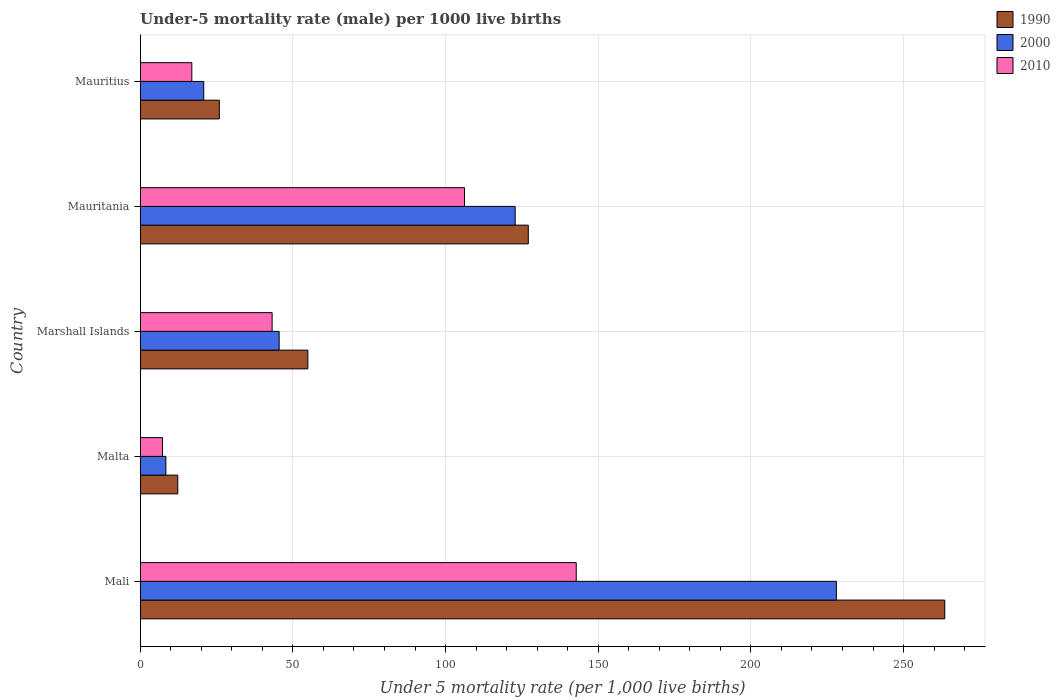How many different coloured bars are there?
Your answer should be compact. 3. Are the number of bars on each tick of the Y-axis equal?
Your answer should be very brief. Yes. How many bars are there on the 2nd tick from the bottom?
Keep it short and to the point. 3. What is the label of the 1st group of bars from the top?
Keep it short and to the point. Mauritius. In how many cases, is the number of bars for a given country not equal to the number of legend labels?
Your answer should be very brief. 0. Across all countries, what is the maximum under-five mortality rate in 1990?
Provide a succinct answer. 263.5. In which country was the under-five mortality rate in 1990 maximum?
Make the answer very short. Mali. In which country was the under-five mortality rate in 2010 minimum?
Your response must be concise. Malta. What is the total under-five mortality rate in 2000 in the graph?
Provide a short and direct response. 425.5. What is the difference between the under-five mortality rate in 1990 in Mali and that in Mauritius?
Make the answer very short. 237.6. What is the difference between the under-five mortality rate in 2000 in Mauritius and the under-five mortality rate in 1990 in Mauritania?
Your answer should be very brief. -106.3. What is the average under-five mortality rate in 1990 per country?
Offer a very short reply. 96.74. What is the difference between the under-five mortality rate in 2010 and under-five mortality rate in 1990 in Marshall Islands?
Make the answer very short. -11.7. In how many countries, is the under-five mortality rate in 2000 greater than 150 ?
Provide a short and direct response. 1. What is the ratio of the under-five mortality rate in 2010 in Mali to that in Marshall Islands?
Provide a succinct answer. 3.31. What is the difference between the highest and the second highest under-five mortality rate in 2000?
Provide a succinct answer. 105.2. What is the difference between the highest and the lowest under-five mortality rate in 2000?
Ensure brevity in your answer.  219.6. In how many countries, is the under-five mortality rate in 1990 greater than the average under-five mortality rate in 1990 taken over all countries?
Give a very brief answer. 2. What does the 3rd bar from the top in Mauritania represents?
Your answer should be compact. 1990. What does the 2nd bar from the bottom in Malta represents?
Keep it short and to the point. 2000. How many bars are there?
Provide a succinct answer. 15. Does the graph contain any zero values?
Provide a short and direct response. No. Does the graph contain grids?
Give a very brief answer. Yes. How many legend labels are there?
Your answer should be very brief. 3. What is the title of the graph?
Your response must be concise. Under-5 mortality rate (male) per 1000 live births. Does "1988" appear as one of the legend labels in the graph?
Provide a short and direct response. No. What is the label or title of the X-axis?
Your response must be concise. Under 5 mortality rate (per 1,0 live births). What is the Under 5 mortality rate (per 1,000 live births) of 1990 in Mali?
Offer a very short reply. 263.5. What is the Under 5 mortality rate (per 1,000 live births) of 2000 in Mali?
Your response must be concise. 228. What is the Under 5 mortality rate (per 1,000 live births) in 2010 in Mali?
Make the answer very short. 142.8. What is the Under 5 mortality rate (per 1,000 live births) in 1990 in Malta?
Offer a very short reply. 12.3. What is the Under 5 mortality rate (per 1,000 live births) of 2000 in Malta?
Provide a short and direct response. 8.4. What is the Under 5 mortality rate (per 1,000 live births) in 1990 in Marshall Islands?
Your answer should be compact. 54.9. What is the Under 5 mortality rate (per 1,000 live births) in 2000 in Marshall Islands?
Ensure brevity in your answer.  45.5. What is the Under 5 mortality rate (per 1,000 live births) in 2010 in Marshall Islands?
Give a very brief answer. 43.2. What is the Under 5 mortality rate (per 1,000 live births) of 1990 in Mauritania?
Your answer should be very brief. 127.1. What is the Under 5 mortality rate (per 1,000 live births) of 2000 in Mauritania?
Provide a succinct answer. 122.8. What is the Under 5 mortality rate (per 1,000 live births) of 2010 in Mauritania?
Give a very brief answer. 106.2. What is the Under 5 mortality rate (per 1,000 live births) of 1990 in Mauritius?
Offer a very short reply. 25.9. What is the Under 5 mortality rate (per 1,000 live births) in 2000 in Mauritius?
Provide a succinct answer. 20.8. What is the Under 5 mortality rate (per 1,000 live births) in 2010 in Mauritius?
Give a very brief answer. 16.9. Across all countries, what is the maximum Under 5 mortality rate (per 1,000 live births) in 1990?
Give a very brief answer. 263.5. Across all countries, what is the maximum Under 5 mortality rate (per 1,000 live births) in 2000?
Offer a very short reply. 228. Across all countries, what is the maximum Under 5 mortality rate (per 1,000 live births) in 2010?
Your response must be concise. 142.8. What is the total Under 5 mortality rate (per 1,000 live births) of 1990 in the graph?
Your answer should be compact. 483.7. What is the total Under 5 mortality rate (per 1,000 live births) in 2000 in the graph?
Your response must be concise. 425.5. What is the total Under 5 mortality rate (per 1,000 live births) in 2010 in the graph?
Make the answer very short. 316.4. What is the difference between the Under 5 mortality rate (per 1,000 live births) in 1990 in Mali and that in Malta?
Your response must be concise. 251.2. What is the difference between the Under 5 mortality rate (per 1,000 live births) of 2000 in Mali and that in Malta?
Your answer should be very brief. 219.6. What is the difference between the Under 5 mortality rate (per 1,000 live births) of 2010 in Mali and that in Malta?
Provide a succinct answer. 135.5. What is the difference between the Under 5 mortality rate (per 1,000 live births) of 1990 in Mali and that in Marshall Islands?
Provide a succinct answer. 208.6. What is the difference between the Under 5 mortality rate (per 1,000 live births) in 2000 in Mali and that in Marshall Islands?
Give a very brief answer. 182.5. What is the difference between the Under 5 mortality rate (per 1,000 live births) of 2010 in Mali and that in Marshall Islands?
Your answer should be compact. 99.6. What is the difference between the Under 5 mortality rate (per 1,000 live births) in 1990 in Mali and that in Mauritania?
Your answer should be compact. 136.4. What is the difference between the Under 5 mortality rate (per 1,000 live births) in 2000 in Mali and that in Mauritania?
Make the answer very short. 105.2. What is the difference between the Under 5 mortality rate (per 1,000 live births) of 2010 in Mali and that in Mauritania?
Provide a succinct answer. 36.6. What is the difference between the Under 5 mortality rate (per 1,000 live births) in 1990 in Mali and that in Mauritius?
Offer a terse response. 237.6. What is the difference between the Under 5 mortality rate (per 1,000 live births) of 2000 in Mali and that in Mauritius?
Your response must be concise. 207.2. What is the difference between the Under 5 mortality rate (per 1,000 live births) in 2010 in Mali and that in Mauritius?
Make the answer very short. 125.9. What is the difference between the Under 5 mortality rate (per 1,000 live births) of 1990 in Malta and that in Marshall Islands?
Your answer should be compact. -42.6. What is the difference between the Under 5 mortality rate (per 1,000 live births) in 2000 in Malta and that in Marshall Islands?
Your answer should be compact. -37.1. What is the difference between the Under 5 mortality rate (per 1,000 live births) of 2010 in Malta and that in Marshall Islands?
Ensure brevity in your answer.  -35.9. What is the difference between the Under 5 mortality rate (per 1,000 live births) in 1990 in Malta and that in Mauritania?
Your answer should be very brief. -114.8. What is the difference between the Under 5 mortality rate (per 1,000 live births) in 2000 in Malta and that in Mauritania?
Offer a terse response. -114.4. What is the difference between the Under 5 mortality rate (per 1,000 live births) in 2010 in Malta and that in Mauritania?
Make the answer very short. -98.9. What is the difference between the Under 5 mortality rate (per 1,000 live births) of 2000 in Malta and that in Mauritius?
Your answer should be compact. -12.4. What is the difference between the Under 5 mortality rate (per 1,000 live births) of 2010 in Malta and that in Mauritius?
Give a very brief answer. -9.6. What is the difference between the Under 5 mortality rate (per 1,000 live births) of 1990 in Marshall Islands and that in Mauritania?
Your answer should be very brief. -72.2. What is the difference between the Under 5 mortality rate (per 1,000 live births) in 2000 in Marshall Islands and that in Mauritania?
Keep it short and to the point. -77.3. What is the difference between the Under 5 mortality rate (per 1,000 live births) in 2010 in Marshall Islands and that in Mauritania?
Offer a terse response. -63. What is the difference between the Under 5 mortality rate (per 1,000 live births) of 2000 in Marshall Islands and that in Mauritius?
Your answer should be compact. 24.7. What is the difference between the Under 5 mortality rate (per 1,000 live births) in 2010 in Marshall Islands and that in Mauritius?
Provide a short and direct response. 26.3. What is the difference between the Under 5 mortality rate (per 1,000 live births) of 1990 in Mauritania and that in Mauritius?
Your answer should be very brief. 101.2. What is the difference between the Under 5 mortality rate (per 1,000 live births) of 2000 in Mauritania and that in Mauritius?
Your answer should be compact. 102. What is the difference between the Under 5 mortality rate (per 1,000 live births) of 2010 in Mauritania and that in Mauritius?
Provide a succinct answer. 89.3. What is the difference between the Under 5 mortality rate (per 1,000 live births) in 1990 in Mali and the Under 5 mortality rate (per 1,000 live births) in 2000 in Malta?
Keep it short and to the point. 255.1. What is the difference between the Under 5 mortality rate (per 1,000 live births) in 1990 in Mali and the Under 5 mortality rate (per 1,000 live births) in 2010 in Malta?
Your answer should be very brief. 256.2. What is the difference between the Under 5 mortality rate (per 1,000 live births) of 2000 in Mali and the Under 5 mortality rate (per 1,000 live births) of 2010 in Malta?
Provide a succinct answer. 220.7. What is the difference between the Under 5 mortality rate (per 1,000 live births) in 1990 in Mali and the Under 5 mortality rate (per 1,000 live births) in 2000 in Marshall Islands?
Your answer should be compact. 218. What is the difference between the Under 5 mortality rate (per 1,000 live births) in 1990 in Mali and the Under 5 mortality rate (per 1,000 live births) in 2010 in Marshall Islands?
Keep it short and to the point. 220.3. What is the difference between the Under 5 mortality rate (per 1,000 live births) in 2000 in Mali and the Under 5 mortality rate (per 1,000 live births) in 2010 in Marshall Islands?
Give a very brief answer. 184.8. What is the difference between the Under 5 mortality rate (per 1,000 live births) in 1990 in Mali and the Under 5 mortality rate (per 1,000 live births) in 2000 in Mauritania?
Your answer should be compact. 140.7. What is the difference between the Under 5 mortality rate (per 1,000 live births) in 1990 in Mali and the Under 5 mortality rate (per 1,000 live births) in 2010 in Mauritania?
Your answer should be very brief. 157.3. What is the difference between the Under 5 mortality rate (per 1,000 live births) in 2000 in Mali and the Under 5 mortality rate (per 1,000 live births) in 2010 in Mauritania?
Offer a terse response. 121.8. What is the difference between the Under 5 mortality rate (per 1,000 live births) in 1990 in Mali and the Under 5 mortality rate (per 1,000 live births) in 2000 in Mauritius?
Offer a very short reply. 242.7. What is the difference between the Under 5 mortality rate (per 1,000 live births) of 1990 in Mali and the Under 5 mortality rate (per 1,000 live births) of 2010 in Mauritius?
Offer a very short reply. 246.6. What is the difference between the Under 5 mortality rate (per 1,000 live births) of 2000 in Mali and the Under 5 mortality rate (per 1,000 live births) of 2010 in Mauritius?
Your answer should be compact. 211.1. What is the difference between the Under 5 mortality rate (per 1,000 live births) in 1990 in Malta and the Under 5 mortality rate (per 1,000 live births) in 2000 in Marshall Islands?
Your response must be concise. -33.2. What is the difference between the Under 5 mortality rate (per 1,000 live births) of 1990 in Malta and the Under 5 mortality rate (per 1,000 live births) of 2010 in Marshall Islands?
Provide a succinct answer. -30.9. What is the difference between the Under 5 mortality rate (per 1,000 live births) of 2000 in Malta and the Under 5 mortality rate (per 1,000 live births) of 2010 in Marshall Islands?
Provide a short and direct response. -34.8. What is the difference between the Under 5 mortality rate (per 1,000 live births) of 1990 in Malta and the Under 5 mortality rate (per 1,000 live births) of 2000 in Mauritania?
Make the answer very short. -110.5. What is the difference between the Under 5 mortality rate (per 1,000 live births) of 1990 in Malta and the Under 5 mortality rate (per 1,000 live births) of 2010 in Mauritania?
Your response must be concise. -93.9. What is the difference between the Under 5 mortality rate (per 1,000 live births) in 2000 in Malta and the Under 5 mortality rate (per 1,000 live births) in 2010 in Mauritania?
Your response must be concise. -97.8. What is the difference between the Under 5 mortality rate (per 1,000 live births) of 1990 in Malta and the Under 5 mortality rate (per 1,000 live births) of 2010 in Mauritius?
Offer a terse response. -4.6. What is the difference between the Under 5 mortality rate (per 1,000 live births) in 1990 in Marshall Islands and the Under 5 mortality rate (per 1,000 live births) in 2000 in Mauritania?
Give a very brief answer. -67.9. What is the difference between the Under 5 mortality rate (per 1,000 live births) of 1990 in Marshall Islands and the Under 5 mortality rate (per 1,000 live births) of 2010 in Mauritania?
Give a very brief answer. -51.3. What is the difference between the Under 5 mortality rate (per 1,000 live births) of 2000 in Marshall Islands and the Under 5 mortality rate (per 1,000 live births) of 2010 in Mauritania?
Keep it short and to the point. -60.7. What is the difference between the Under 5 mortality rate (per 1,000 live births) of 1990 in Marshall Islands and the Under 5 mortality rate (per 1,000 live births) of 2000 in Mauritius?
Your answer should be very brief. 34.1. What is the difference between the Under 5 mortality rate (per 1,000 live births) in 2000 in Marshall Islands and the Under 5 mortality rate (per 1,000 live births) in 2010 in Mauritius?
Keep it short and to the point. 28.6. What is the difference between the Under 5 mortality rate (per 1,000 live births) in 1990 in Mauritania and the Under 5 mortality rate (per 1,000 live births) in 2000 in Mauritius?
Provide a short and direct response. 106.3. What is the difference between the Under 5 mortality rate (per 1,000 live births) in 1990 in Mauritania and the Under 5 mortality rate (per 1,000 live births) in 2010 in Mauritius?
Make the answer very short. 110.2. What is the difference between the Under 5 mortality rate (per 1,000 live births) in 2000 in Mauritania and the Under 5 mortality rate (per 1,000 live births) in 2010 in Mauritius?
Provide a succinct answer. 105.9. What is the average Under 5 mortality rate (per 1,000 live births) in 1990 per country?
Keep it short and to the point. 96.74. What is the average Under 5 mortality rate (per 1,000 live births) of 2000 per country?
Keep it short and to the point. 85.1. What is the average Under 5 mortality rate (per 1,000 live births) in 2010 per country?
Provide a succinct answer. 63.28. What is the difference between the Under 5 mortality rate (per 1,000 live births) of 1990 and Under 5 mortality rate (per 1,000 live births) of 2000 in Mali?
Give a very brief answer. 35.5. What is the difference between the Under 5 mortality rate (per 1,000 live births) in 1990 and Under 5 mortality rate (per 1,000 live births) in 2010 in Mali?
Your answer should be very brief. 120.7. What is the difference between the Under 5 mortality rate (per 1,000 live births) of 2000 and Under 5 mortality rate (per 1,000 live births) of 2010 in Mali?
Ensure brevity in your answer.  85.2. What is the difference between the Under 5 mortality rate (per 1,000 live births) in 1990 and Under 5 mortality rate (per 1,000 live births) in 2010 in Malta?
Your response must be concise. 5. What is the difference between the Under 5 mortality rate (per 1,000 live births) of 1990 and Under 5 mortality rate (per 1,000 live births) of 2010 in Marshall Islands?
Ensure brevity in your answer.  11.7. What is the difference between the Under 5 mortality rate (per 1,000 live births) in 1990 and Under 5 mortality rate (per 1,000 live births) in 2010 in Mauritania?
Your response must be concise. 20.9. What is the difference between the Under 5 mortality rate (per 1,000 live births) in 2000 and Under 5 mortality rate (per 1,000 live births) in 2010 in Mauritania?
Keep it short and to the point. 16.6. What is the difference between the Under 5 mortality rate (per 1,000 live births) in 1990 and Under 5 mortality rate (per 1,000 live births) in 2000 in Mauritius?
Your answer should be compact. 5.1. What is the difference between the Under 5 mortality rate (per 1,000 live births) in 2000 and Under 5 mortality rate (per 1,000 live births) in 2010 in Mauritius?
Provide a succinct answer. 3.9. What is the ratio of the Under 5 mortality rate (per 1,000 live births) in 1990 in Mali to that in Malta?
Ensure brevity in your answer.  21.42. What is the ratio of the Under 5 mortality rate (per 1,000 live births) of 2000 in Mali to that in Malta?
Your response must be concise. 27.14. What is the ratio of the Under 5 mortality rate (per 1,000 live births) in 2010 in Mali to that in Malta?
Ensure brevity in your answer.  19.56. What is the ratio of the Under 5 mortality rate (per 1,000 live births) of 1990 in Mali to that in Marshall Islands?
Your response must be concise. 4.8. What is the ratio of the Under 5 mortality rate (per 1,000 live births) in 2000 in Mali to that in Marshall Islands?
Your answer should be very brief. 5.01. What is the ratio of the Under 5 mortality rate (per 1,000 live births) of 2010 in Mali to that in Marshall Islands?
Your response must be concise. 3.31. What is the ratio of the Under 5 mortality rate (per 1,000 live births) in 1990 in Mali to that in Mauritania?
Offer a terse response. 2.07. What is the ratio of the Under 5 mortality rate (per 1,000 live births) of 2000 in Mali to that in Mauritania?
Your answer should be very brief. 1.86. What is the ratio of the Under 5 mortality rate (per 1,000 live births) of 2010 in Mali to that in Mauritania?
Your answer should be compact. 1.34. What is the ratio of the Under 5 mortality rate (per 1,000 live births) of 1990 in Mali to that in Mauritius?
Your answer should be very brief. 10.17. What is the ratio of the Under 5 mortality rate (per 1,000 live births) in 2000 in Mali to that in Mauritius?
Provide a short and direct response. 10.96. What is the ratio of the Under 5 mortality rate (per 1,000 live births) of 2010 in Mali to that in Mauritius?
Offer a terse response. 8.45. What is the ratio of the Under 5 mortality rate (per 1,000 live births) in 1990 in Malta to that in Marshall Islands?
Give a very brief answer. 0.22. What is the ratio of the Under 5 mortality rate (per 1,000 live births) in 2000 in Malta to that in Marshall Islands?
Provide a short and direct response. 0.18. What is the ratio of the Under 5 mortality rate (per 1,000 live births) of 2010 in Malta to that in Marshall Islands?
Keep it short and to the point. 0.17. What is the ratio of the Under 5 mortality rate (per 1,000 live births) in 1990 in Malta to that in Mauritania?
Offer a terse response. 0.1. What is the ratio of the Under 5 mortality rate (per 1,000 live births) of 2000 in Malta to that in Mauritania?
Ensure brevity in your answer.  0.07. What is the ratio of the Under 5 mortality rate (per 1,000 live births) in 2010 in Malta to that in Mauritania?
Make the answer very short. 0.07. What is the ratio of the Under 5 mortality rate (per 1,000 live births) of 1990 in Malta to that in Mauritius?
Make the answer very short. 0.47. What is the ratio of the Under 5 mortality rate (per 1,000 live births) of 2000 in Malta to that in Mauritius?
Provide a succinct answer. 0.4. What is the ratio of the Under 5 mortality rate (per 1,000 live births) in 2010 in Malta to that in Mauritius?
Make the answer very short. 0.43. What is the ratio of the Under 5 mortality rate (per 1,000 live births) in 1990 in Marshall Islands to that in Mauritania?
Your response must be concise. 0.43. What is the ratio of the Under 5 mortality rate (per 1,000 live births) in 2000 in Marshall Islands to that in Mauritania?
Offer a very short reply. 0.37. What is the ratio of the Under 5 mortality rate (per 1,000 live births) of 2010 in Marshall Islands to that in Mauritania?
Give a very brief answer. 0.41. What is the ratio of the Under 5 mortality rate (per 1,000 live births) in 1990 in Marshall Islands to that in Mauritius?
Your response must be concise. 2.12. What is the ratio of the Under 5 mortality rate (per 1,000 live births) in 2000 in Marshall Islands to that in Mauritius?
Offer a very short reply. 2.19. What is the ratio of the Under 5 mortality rate (per 1,000 live births) of 2010 in Marshall Islands to that in Mauritius?
Offer a terse response. 2.56. What is the ratio of the Under 5 mortality rate (per 1,000 live births) of 1990 in Mauritania to that in Mauritius?
Your answer should be compact. 4.91. What is the ratio of the Under 5 mortality rate (per 1,000 live births) in 2000 in Mauritania to that in Mauritius?
Offer a terse response. 5.9. What is the ratio of the Under 5 mortality rate (per 1,000 live births) in 2010 in Mauritania to that in Mauritius?
Your response must be concise. 6.28. What is the difference between the highest and the second highest Under 5 mortality rate (per 1,000 live births) of 1990?
Provide a succinct answer. 136.4. What is the difference between the highest and the second highest Under 5 mortality rate (per 1,000 live births) in 2000?
Your answer should be compact. 105.2. What is the difference between the highest and the second highest Under 5 mortality rate (per 1,000 live births) in 2010?
Provide a short and direct response. 36.6. What is the difference between the highest and the lowest Under 5 mortality rate (per 1,000 live births) of 1990?
Make the answer very short. 251.2. What is the difference between the highest and the lowest Under 5 mortality rate (per 1,000 live births) in 2000?
Your response must be concise. 219.6. What is the difference between the highest and the lowest Under 5 mortality rate (per 1,000 live births) of 2010?
Offer a very short reply. 135.5. 